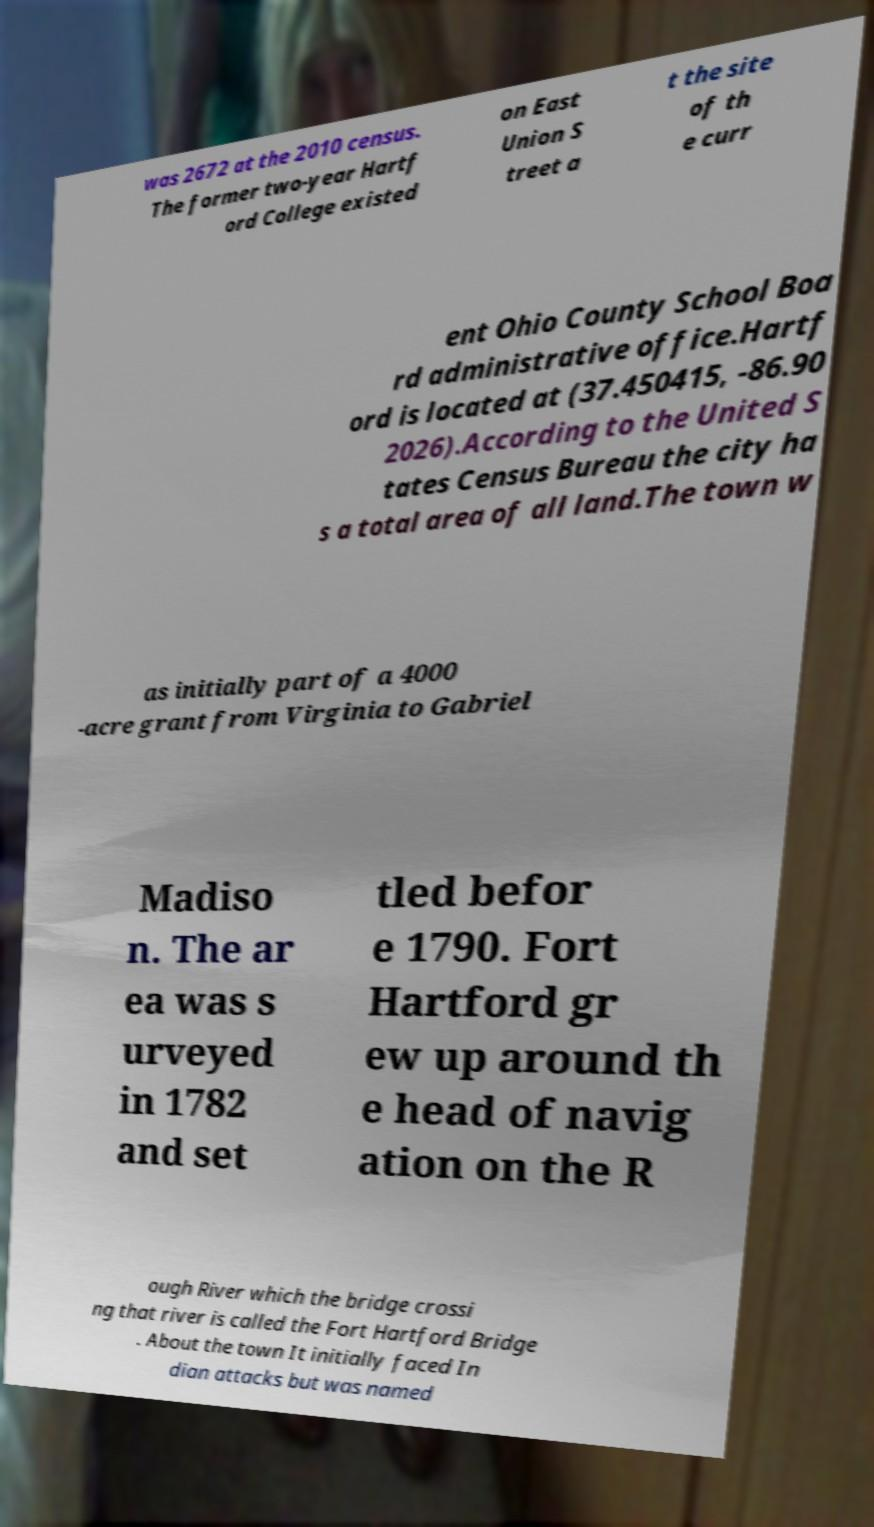Could you extract and type out the text from this image? was 2672 at the 2010 census. The former two-year Hartf ord College existed on East Union S treet a t the site of th e curr ent Ohio County School Boa rd administrative office.Hartf ord is located at (37.450415, -86.90 2026).According to the United S tates Census Bureau the city ha s a total area of all land.The town w as initially part of a 4000 -acre grant from Virginia to Gabriel Madiso n. The ar ea was s urveyed in 1782 and set tled befor e 1790. Fort Hartford gr ew up around th e head of navig ation on the R ough River which the bridge crossi ng that river is called the Fort Hartford Bridge . About the town It initially faced In dian attacks but was named 